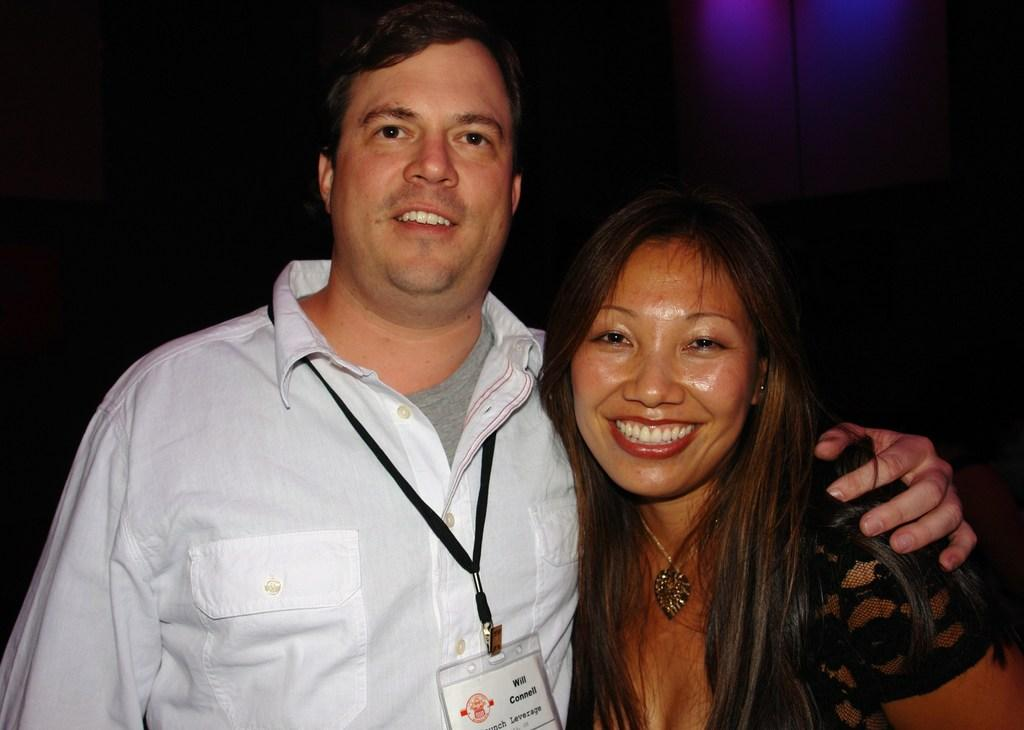What are the two people in the image doing? The man and woman are standing together in the image. Can you describe the appearance of the man and woman? The provided facts do not mention the appearance of the man and woman. What is the man wearing that is mentioned in the facts? The man is wearing a tag. What type of joke is the rabbit telling in the image? There is no rabbit present in the image, and therefore no such joke-telling activity can be observed. What type of wood is the man holding in the image? There is no wood present in the image; the man is wearing a tag. 